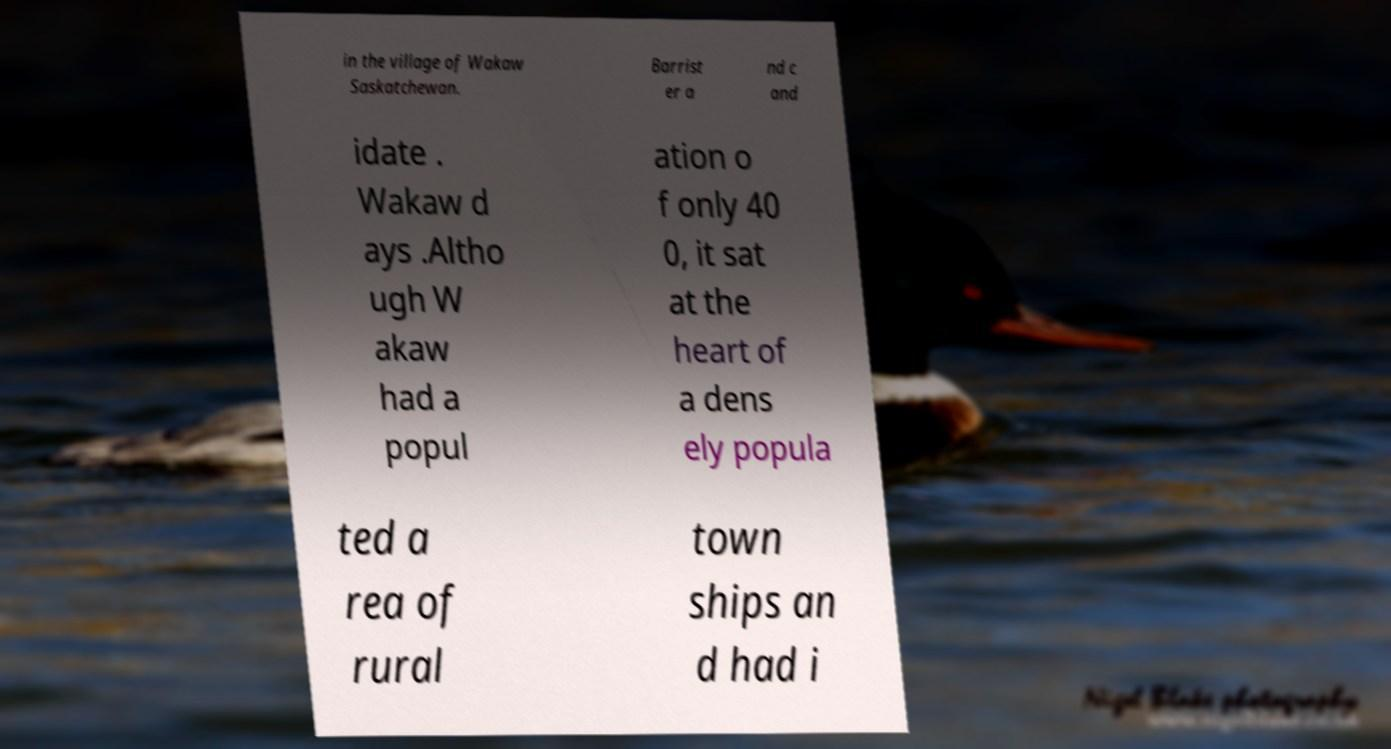Please read and relay the text visible in this image. What does it say? in the village of Wakaw Saskatchewan. Barrist er a nd c and idate . Wakaw d ays .Altho ugh W akaw had a popul ation o f only 40 0, it sat at the heart of a dens ely popula ted a rea of rural town ships an d had i 